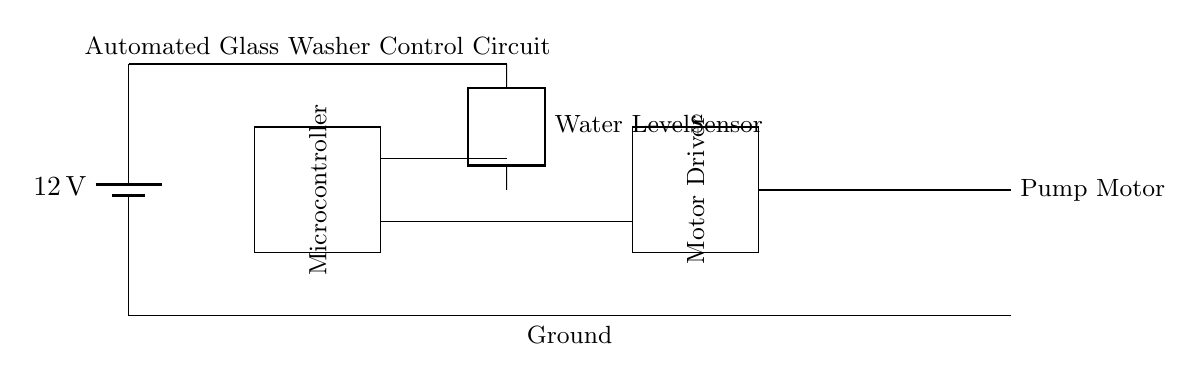What is the main power supply voltage in the circuit? The circuit is powered by a 12-volt battery, indicated at the top left of the diagram.
Answer: 12 volts What component controls the pump motor? The pump motor is controlled by the motor driver component, which is directly connected to it.
Answer: Motor driver How does the water level sensor interact with the microcontroller? The water level sensor sends signals to the microcontroller, which processes this information to control the motor driver. This connection is shown by the line between the sensor and the microcontroller.
Answer: Sends signals What does the microcontroller do? The microcontroller processes data from the water level sensor to determine when to activate the pump motor through the motor driver.
Answer: Controls operations How many main electrical components are in this circuit? The circuit contains four main components: a battery, microcontroller, motor driver, and pump motor, along with the water level sensor.
Answer: Four Which component is located at the bottom of the circuit diagram? The ground connection is located at the bottom section of the circuit diagram, providing a reference point for other components.
Answer: Ground What is the function of the pump motor in this circuit? The pump motor serves the function of moving water, driven by the control signals from the motor driver based on the microcontroller's instructions.
Answer: Moves water 